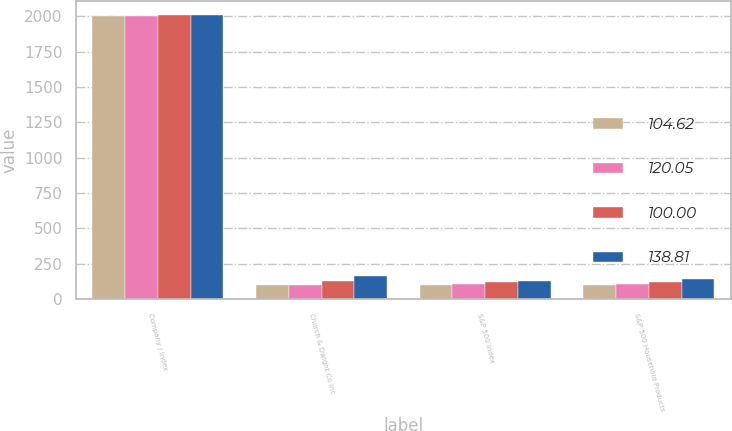<chart> <loc_0><loc_0><loc_500><loc_500><stacked_bar_chart><ecel><fcel>Company / Index<fcel>Church & Dwight Co Inc<fcel>S&P 500 Index<fcel>S&P 500 Household Products<nl><fcel>104.62<fcel>2004<fcel>100<fcel>100<fcel>100<nl><fcel>120.05<fcel>2005<fcel>98.91<fcel>104.91<fcel>104.62<nl><fcel>100<fcel>2006<fcel>128.6<fcel>121.48<fcel>120.05<nl><fcel>138.81<fcel>2007<fcel>164.02<fcel>128.16<fcel>138.81<nl></chart> 